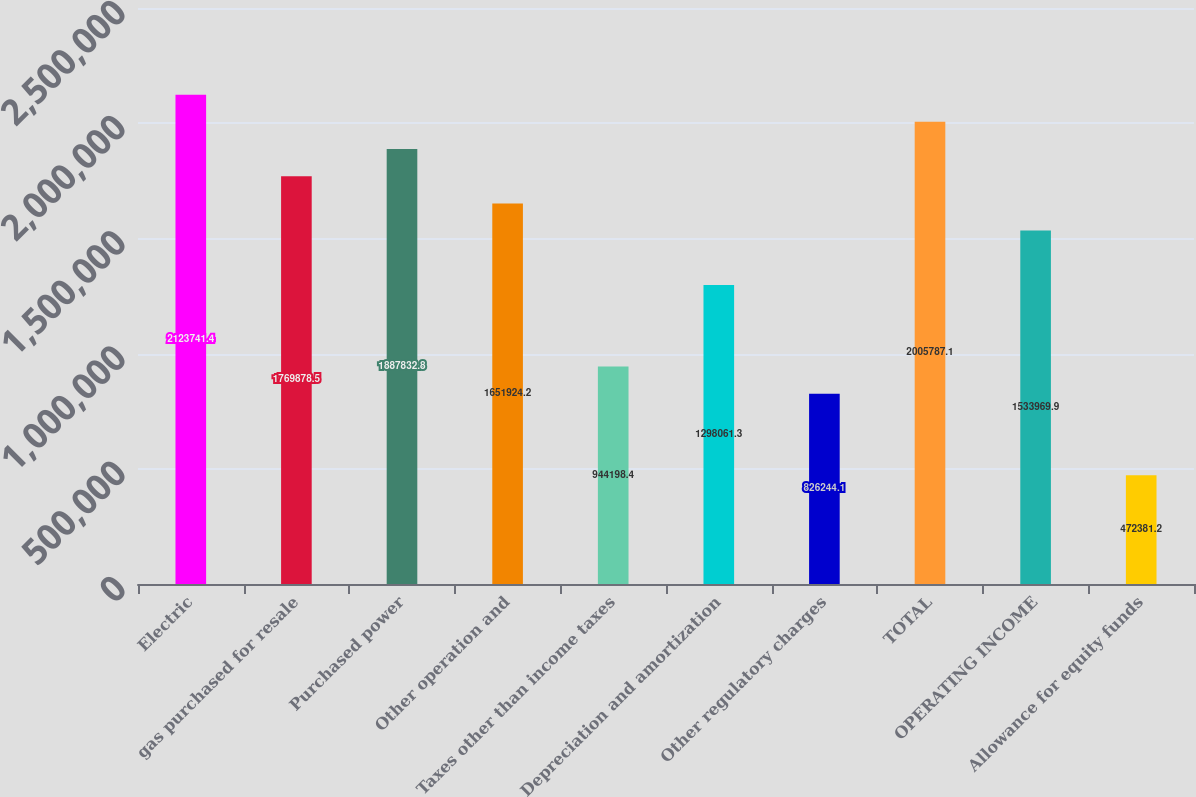Convert chart to OTSL. <chart><loc_0><loc_0><loc_500><loc_500><bar_chart><fcel>Electric<fcel>gas purchased for resale<fcel>Purchased power<fcel>Other operation and<fcel>Taxes other than income taxes<fcel>Depreciation and amortization<fcel>Other regulatory charges<fcel>TOTAL<fcel>OPERATING INCOME<fcel>Allowance for equity funds<nl><fcel>2.12374e+06<fcel>1.76988e+06<fcel>1.88783e+06<fcel>1.65192e+06<fcel>944198<fcel>1.29806e+06<fcel>826244<fcel>2.00579e+06<fcel>1.53397e+06<fcel>472381<nl></chart> 